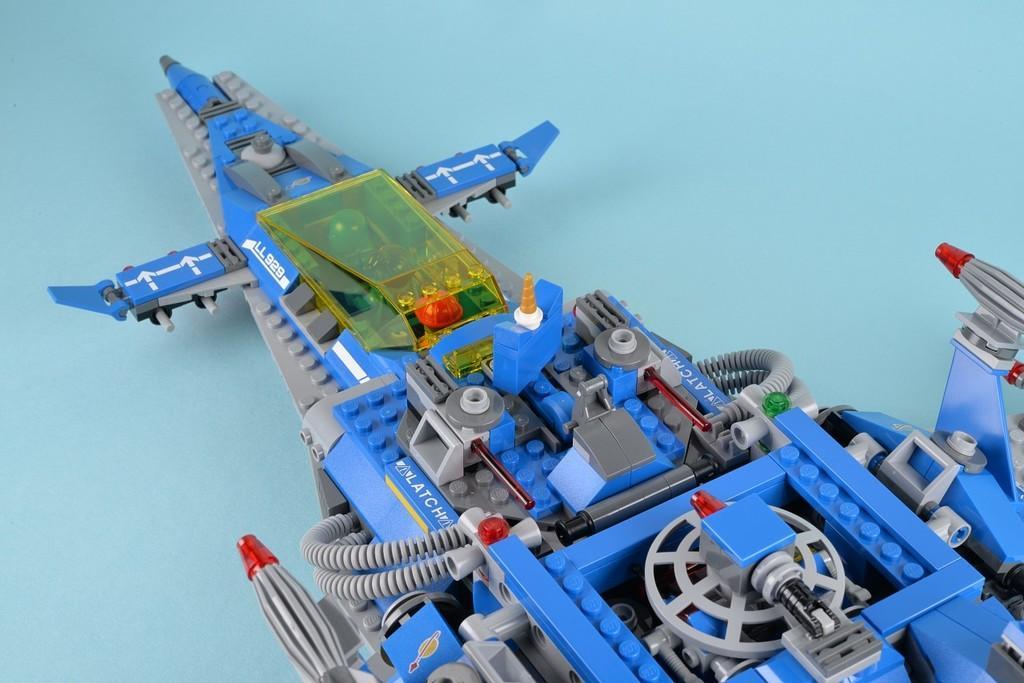Could you give a brief overview of what you see in this image? In the middle of the image there is a toy plane on the surface. The surface is light blue in color. 